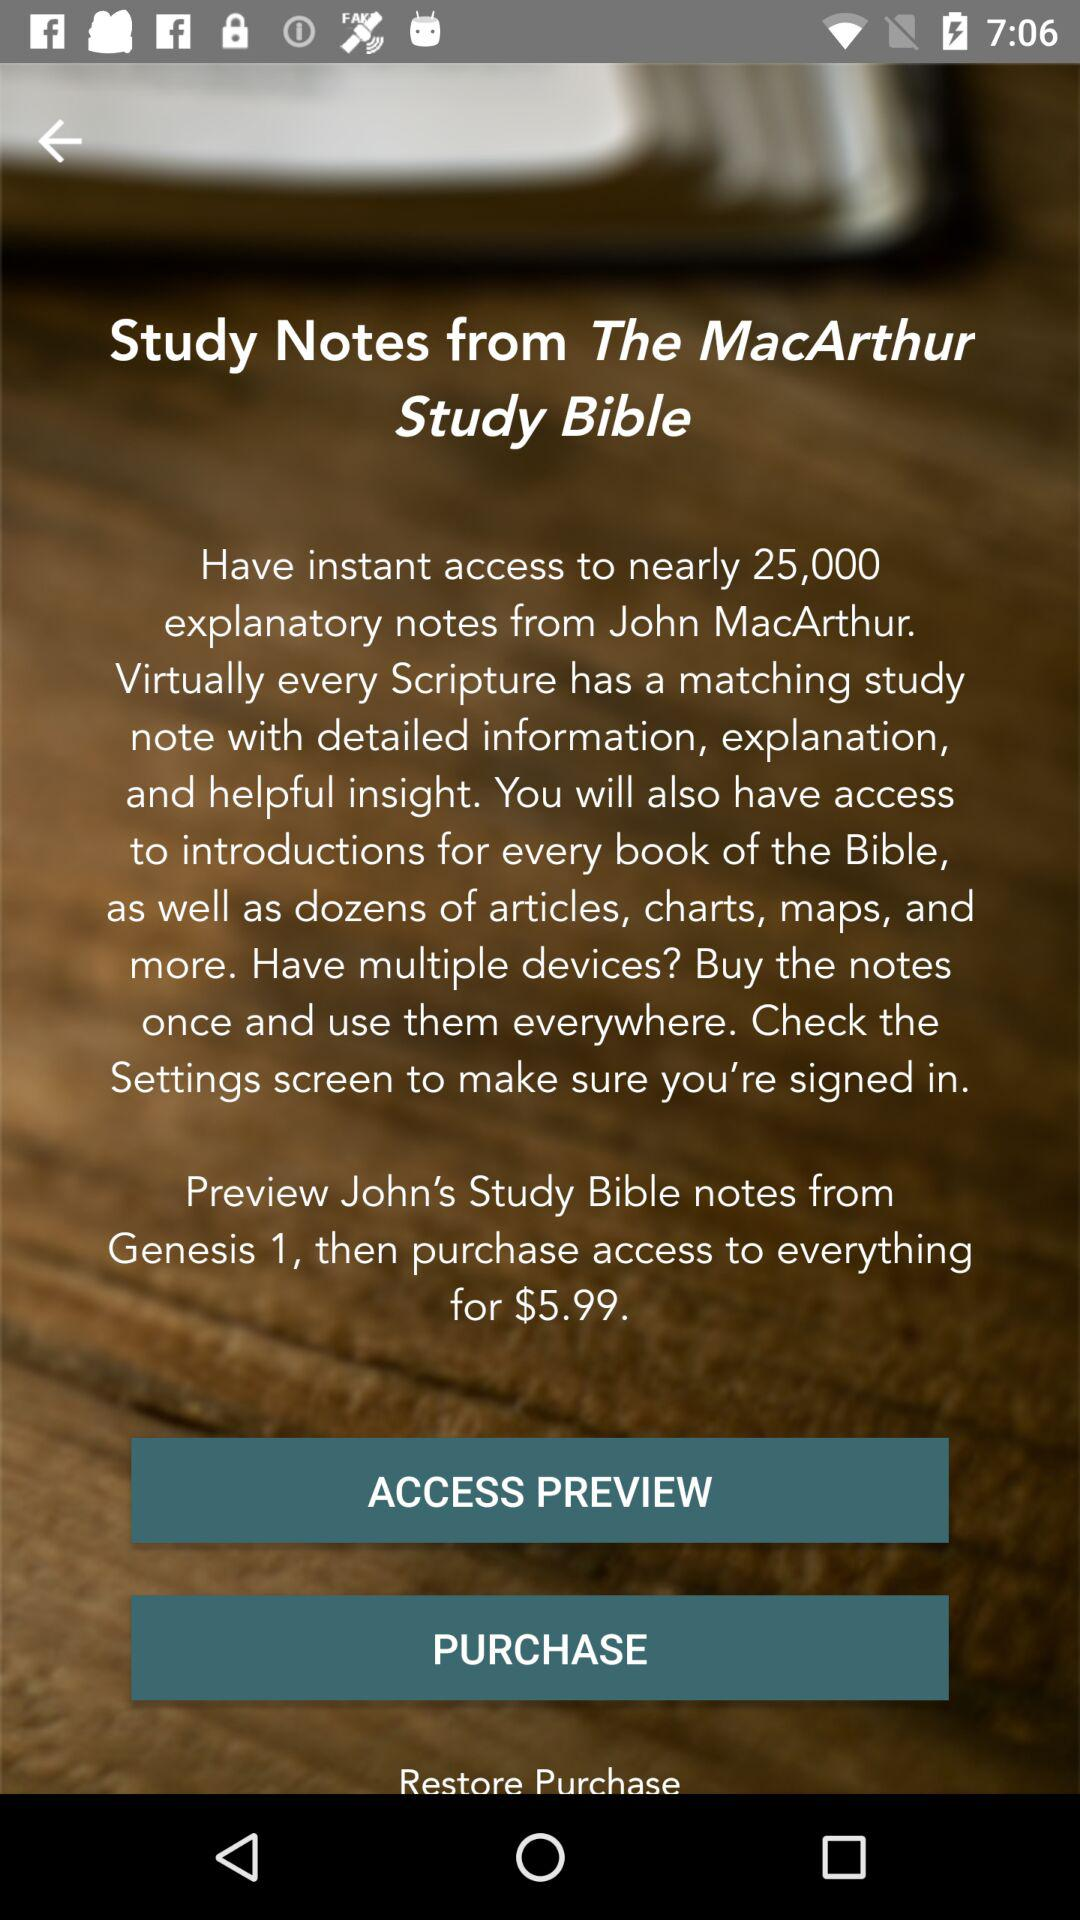What is the name of the application? The name of the application is "Study Bible". 